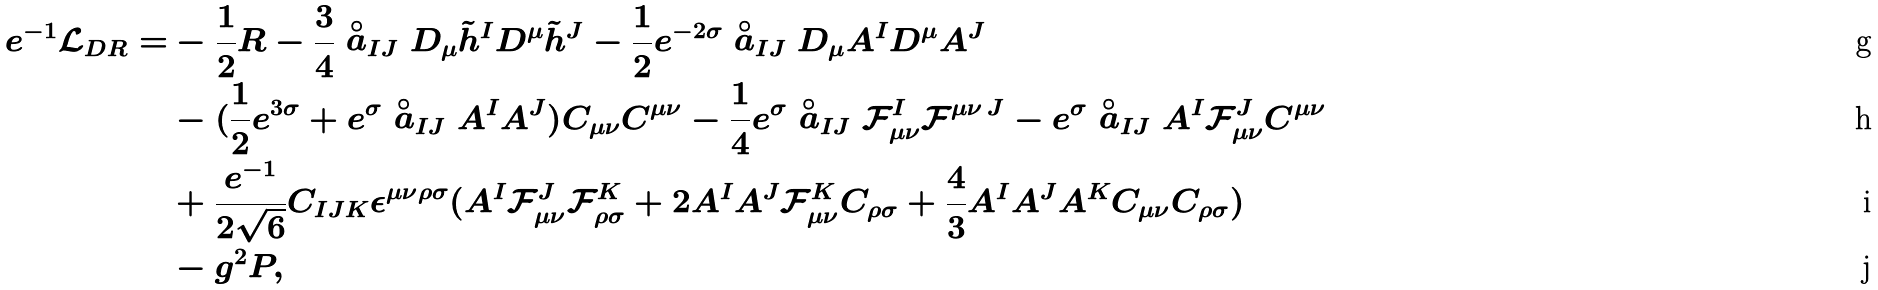<formula> <loc_0><loc_0><loc_500><loc_500>e ^ { - 1 } \mathcal { L } _ { D R } = & - \frac { 1 } { 2 } R - \frac { 3 } { 4 } \stackrel { \circ } { a } _ { I J } D _ { \mu } \tilde { h } ^ { I } D ^ { \mu } \tilde { h } ^ { J } - \frac { 1 } { 2 } e ^ { - 2 \sigma } \stackrel { \circ } { a } _ { I J } D _ { \mu } A ^ { I } D ^ { \mu } A ^ { J } \\ & - ( \frac { 1 } { 2 } e ^ { 3 \sigma } + e ^ { \sigma } \stackrel { \circ } { a } _ { I J } A ^ { I } A ^ { J } ) C _ { \mu \nu } C ^ { \mu \nu } - \frac { 1 } { 4 } e ^ { \sigma } \stackrel { \circ } { a } _ { I J } \mathcal { F } ^ { I } _ { \mu \nu } \mathcal { F } ^ { \mu \nu \, J } - e ^ { \sigma } \stackrel { \circ } { a } _ { I J } A ^ { I } \mathcal { F } ^ { J } _ { \mu \nu } C ^ { \mu \nu } \\ & + \frac { e ^ { - 1 } } { 2 \sqrt { 6 } } C _ { I J K } \epsilon ^ { \mu \nu \rho \sigma } ( A ^ { I } \mathcal { F } ^ { J } _ { \mu \nu } \mathcal { F } ^ { K } _ { \rho \sigma } + 2 A ^ { I } A ^ { J } \mathcal { F } ^ { K } _ { \mu \nu } C _ { \rho \sigma } + \frac { 4 } { 3 } A ^ { I } A ^ { J } A ^ { K } C _ { \mu \nu } C _ { \rho \sigma } ) \\ & - g ^ { 2 } P ,</formula> 